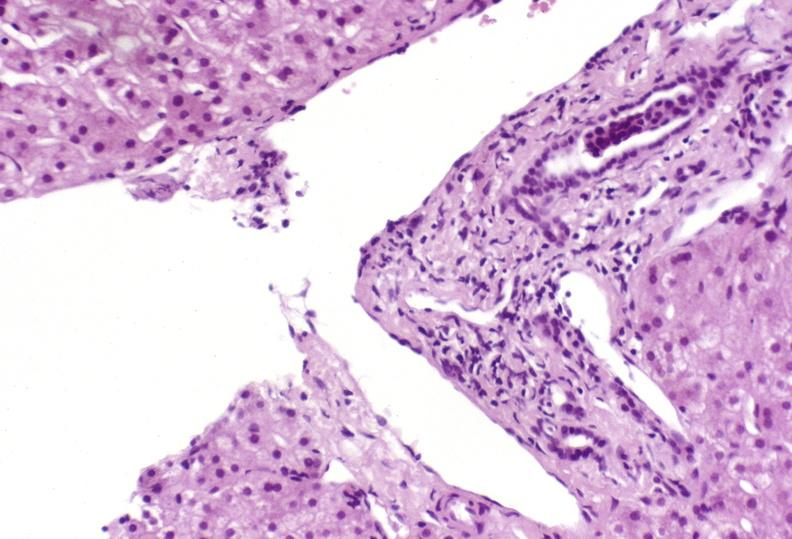what is present?
Answer the question using a single word or phrase. Hepatobiliary 